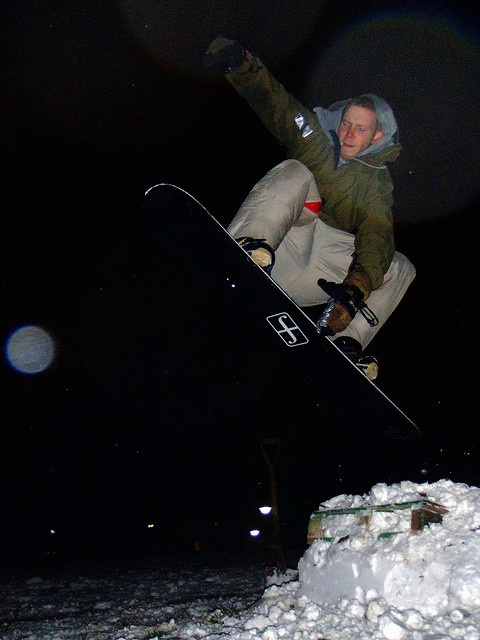Describe the objects in this image and their specific colors. I can see people in black and gray tones and snowboard in black, gray, darkgray, and lightgray tones in this image. 